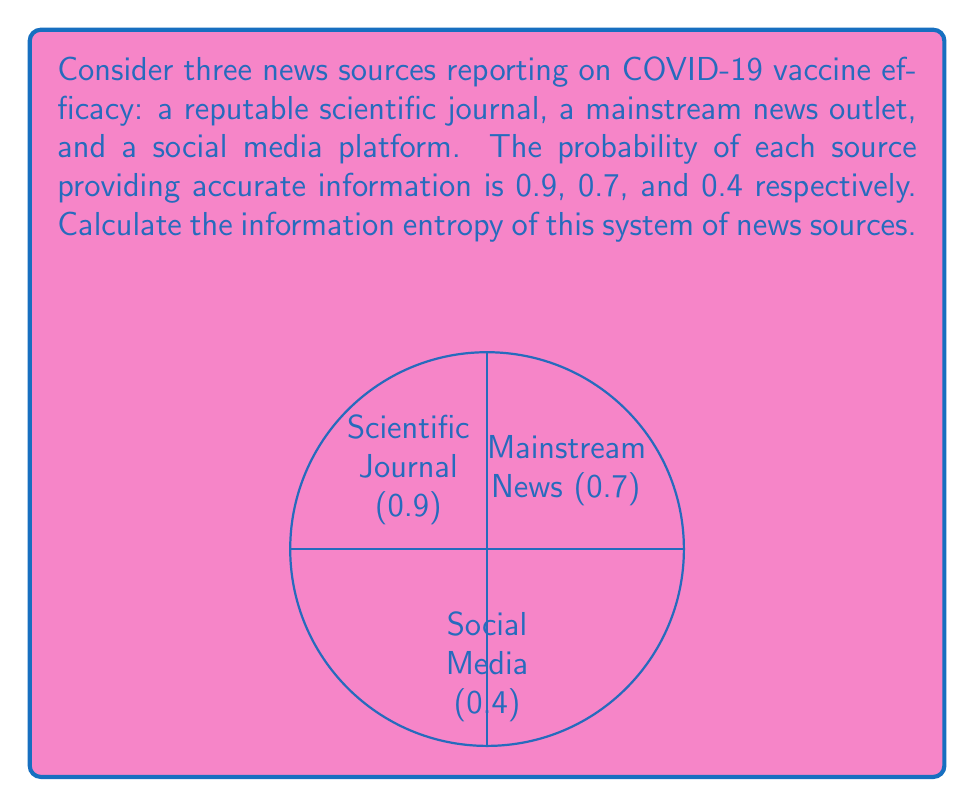Provide a solution to this math problem. To calculate the information entropy of this system, we'll use the formula for Shannon entropy:

$$ H = -\sum_{i=1}^{n} p_i \log_2(p_i) $$

Where $p_i$ is the probability of each outcome.

Step 1: Identify the probabilities
$p_1 = 0.9$ (Scientific Journal)
$p_2 = 0.7$ (Mainstream News)
$p_3 = 0.4$ (Social Media)

Step 2: Calculate each term in the sum
For Scientific Journal:
$-0.9 \log_2(0.9) = 0.1368$

For Mainstream News:
$-0.7 \log_2(0.7) = 0.3601$

For Social Media:
$-0.4 \log_2(0.4) = 0.5288$

Step 3: Sum all terms
$H = 0.1368 + 0.3601 + 0.5288 = 1.0257$

The information entropy of this system is approximately 1.0257 bits.

This value indicates the average amount of information or uncertainty in the system. A higher entropy suggests more uncertainty or diversity in the information sources, which aligns with the varying reliability of different news sources regarding COVID-19 vaccine information.
Answer: 1.0257 bits 